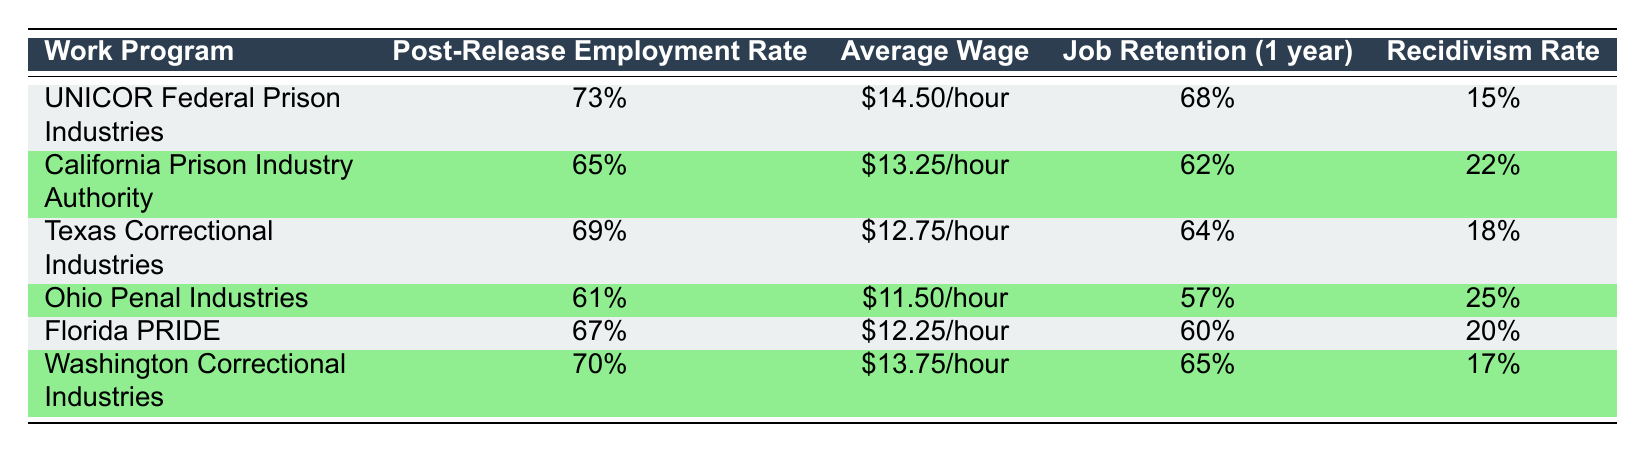What is the Post-Release Employment Rate for Florida PRIDE? The table shows that the Post-Release Employment Rate for Florida PRIDE is listed as 67%.
Answer: 67% Which work program has the highest average wage? According to the table, UNICOR Federal Prison Industries has the highest average wage at $14.50/hour.
Answer: $14.50/hour What is the average Post-Release Employment Rate for all programs? To find the average, sum the individual rates: 73 + 65 + 69 + 61 + 67 + 70 = 405, then divide by the number of programs (6). The average employment rate is 405 / 6 = 67.5%.
Answer: 67.5% Is the Recidivism Rate for Ohio Penal Industries higher than that of California Prison Industry Authority? The Recidivism Rate for Ohio Penal Industries is 25%, while for California Prison Industry Authority it is 22%. Since 25% is greater than 22%, the statement is true.
Answer: Yes Which work program has the lowest Job Retention rate? The table states that Ohio Penal Industries has the lowest Job Retention rate at 57%.
Answer: 57% What is the difference in the Post-Release Employment Rate between UNICOR Federal Prison Industries and Texas Correctional Industries? UNICOR Federal Prison Industries has a rate of 73% and Texas Correctional Industries has a rate of 69%. The difference is 73% - 69% = 4%.
Answer: 4% Which work program has a Recidivism Rate less than 20%? Looking at the table, UNICOR Federal Prison Industries has a Recidivism Rate of 15%, which is less than 20%. Thus, this is the only program that meets the criterion.
Answer: UNICOR Federal Prison Industries What is the median Average Wage among all the work programs? First, list the average wages in order: $11.50, $12.25, $12.75, $13.25, $13.75, $14.50. The median is the average of the 3rd and 4th values ($12.75 + $13.25) / 2 = $13.00.
Answer: $13.00 